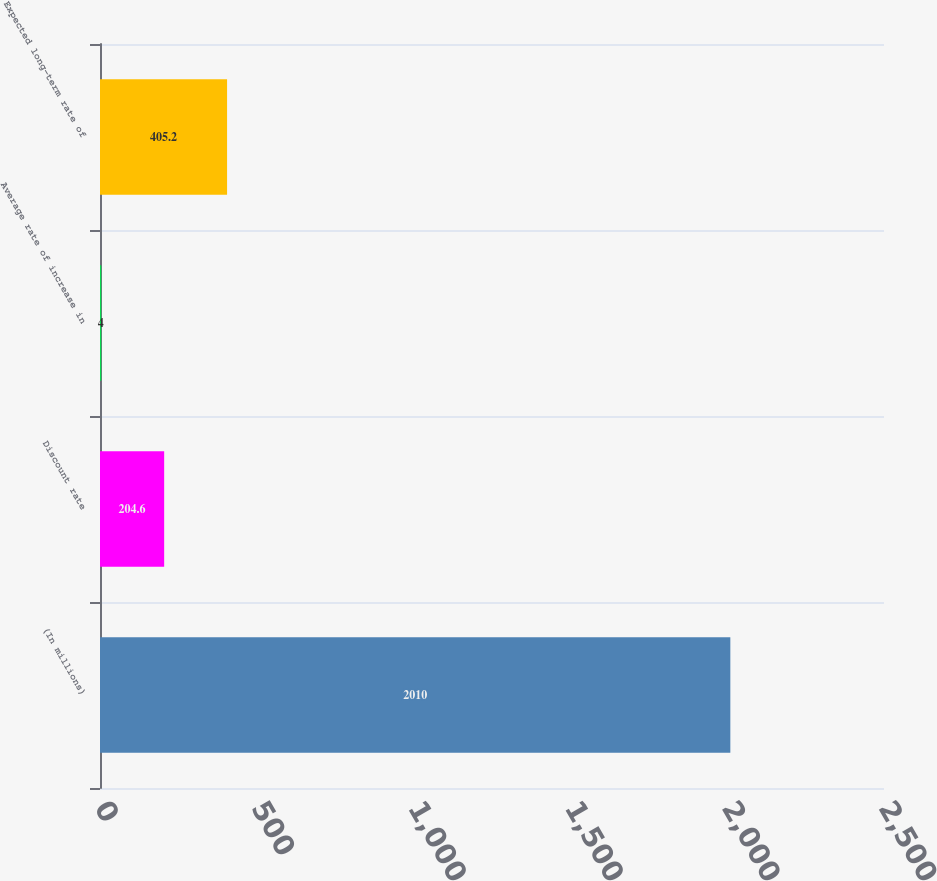Convert chart to OTSL. <chart><loc_0><loc_0><loc_500><loc_500><bar_chart><fcel>(In millions)<fcel>Discount rate<fcel>Average rate of increase in<fcel>Expected long-term rate of<nl><fcel>2010<fcel>204.6<fcel>4<fcel>405.2<nl></chart> 